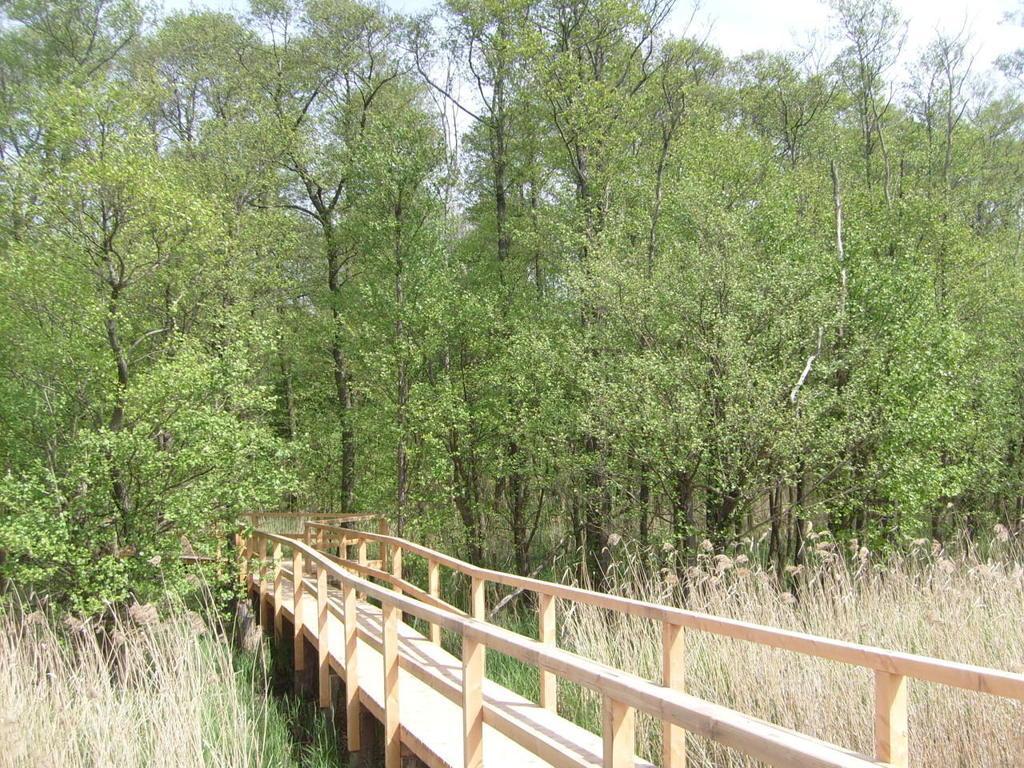In one or two sentences, can you explain what this image depicts? In this image we can see the wooden bridge, there are trees, grass, plants, also we can see the sky. 